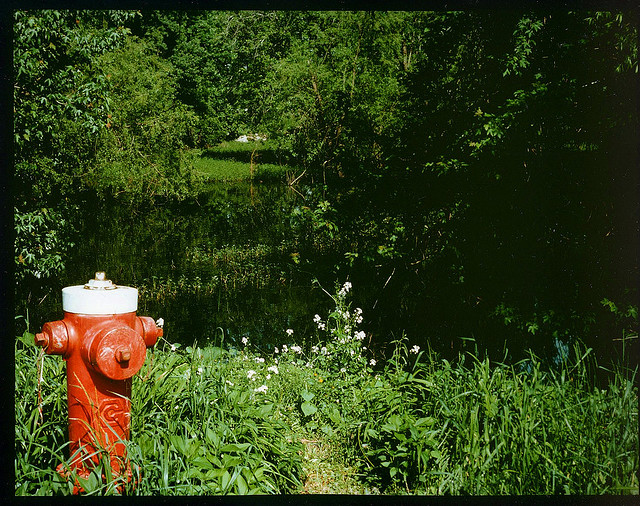<image>What letters are on the hydrant? I am not sure what letters are on the hydrant. It could be 'cs', 'c', 'g', or there might be no letters at all. The tree behind the fire hydrant has what kind of effect over it? It is ambiguous what kind of effect the tree has over the fire hydrant. It could be shadowing, cooling or none at all. Where is the hydrant? It is unknown where exactly the hydrant is located. It could be in the grass. Which presidential last name is on the fire hydrant? I don't know which presidential last name is on the fire hydrant. It may be 'carter', 'cleveland', 'washington', 'clinton', or 'roosevelt'. What is the large structure behind the fire hydrant used for? It is unknown what the large structure behind the fire hydrant is used for. It could be for swimming, living, or irrigation. What number is on the fire hydrant? It's unclear what number is on the fire hydrant. The answers vary from '0', '1', 'c', '5', to '4'. What letters are on the hydrant? It is ambiguous what letters are on the hydrant. It can be seen 'cs', 'c' or 'g'. The tree behind the fire hydrant has what kind of effect over it? I don't know what kind of effect the tree behind the fire hydrant has over it. It can be seen as shadow, throwing shade, cooling, reflective, or towering. Where is the hydrant? I don't know where the hydrant is. It can be seen in the grass or on the left. Which presidential last name is on the fire hydrant? It is not clear which presidential last name is on the fire hydrant. There is no name visible. What is the large structure behind the fire hydrant used for? I am not sure what the large structure behind the fire hydrant is used for. It can be used for swimming, living, pond, dwelling, irrigation, water or anything else. What number is on the fire hydrant? I don't know what number is on the fire hydrant. It can be seen as '0', '1', 'c', 'unclear', '5' or '4'. 